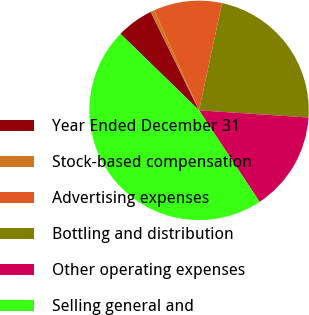<chart> <loc_0><loc_0><loc_500><loc_500><pie_chart><fcel>Year Ended December 31<fcel>Stock-based compensation<fcel>Advertising expenses<fcel>Bottling and distribution<fcel>Other operating expenses<fcel>Selling general and<nl><fcel>5.45%<fcel>0.57%<fcel>10.05%<fcel>22.68%<fcel>14.66%<fcel>46.59%<nl></chart> 